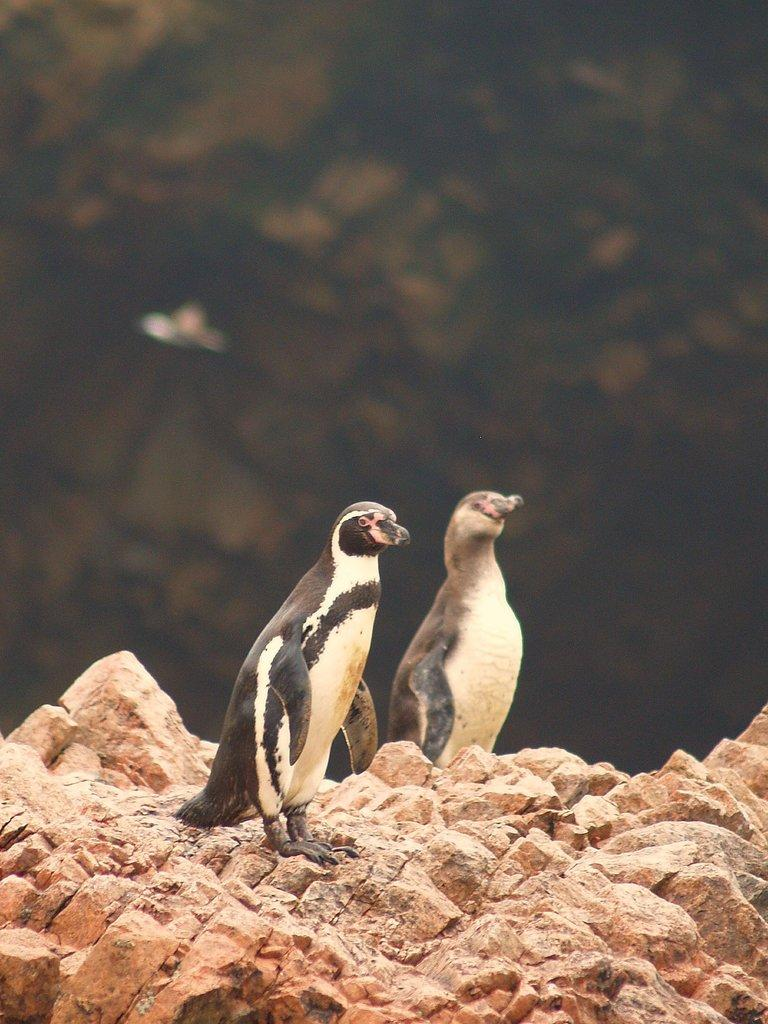What animals are present in the image? There are two penguins in the image. Where are the penguins located? The penguins are on rocks. Can you describe the background of the image? The background of the image is blurred. What type of form can be seen in the liquid in the image? There is no liquid present in the image, so it is not possible to determine the form of any liquid. 